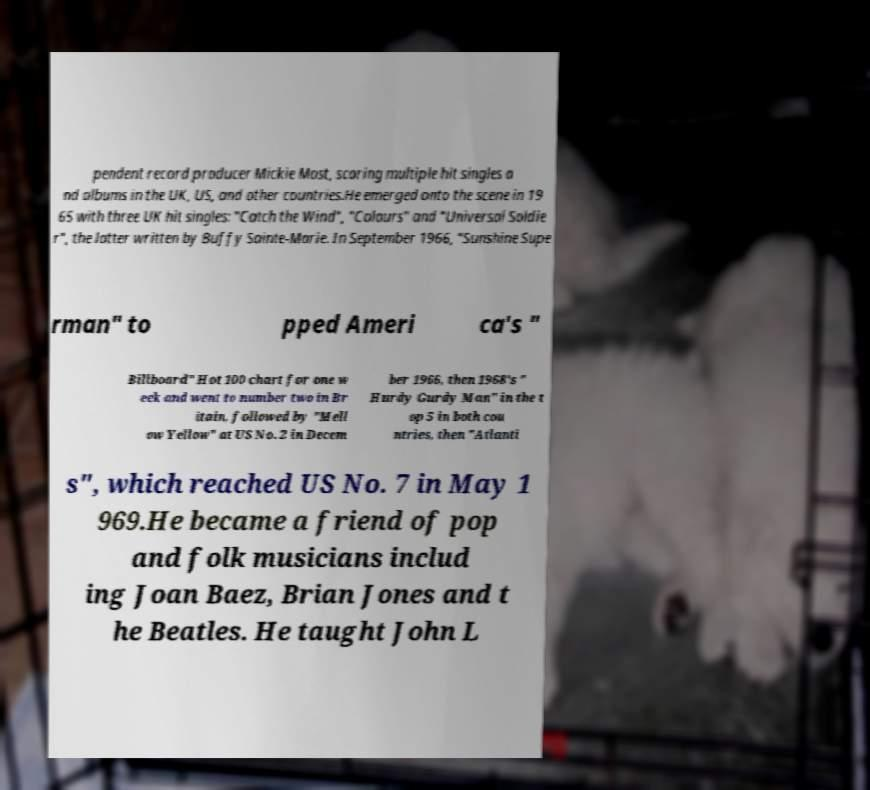Could you extract and type out the text from this image? pendent record producer Mickie Most, scoring multiple hit singles a nd albums in the UK, US, and other countries.He emerged onto the scene in 19 65 with three UK hit singles: "Catch the Wind", "Colours" and "Universal Soldie r", the latter written by Buffy Sainte-Marie. In September 1966, "Sunshine Supe rman" to pped Ameri ca's " Billboard" Hot 100 chart for one w eek and went to number two in Br itain, followed by "Mell ow Yellow" at US No. 2 in Decem ber 1966, then 1968's " Hurdy Gurdy Man" in the t op 5 in both cou ntries, then "Atlanti s", which reached US No. 7 in May 1 969.He became a friend of pop and folk musicians includ ing Joan Baez, Brian Jones and t he Beatles. He taught John L 